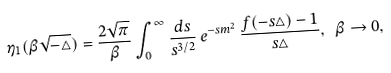<formula> <loc_0><loc_0><loc_500><loc_500>\eta _ { 1 } ( \beta \sqrt { - \triangle } ) = \frac { 2 \sqrt { \pi } } { \beta } \int _ { 0 } ^ { \infty } \frac { { d } s } { s ^ { 3 / 2 } } \, { e } ^ { - s m ^ { 2 } } \, \frac { f ( - s \triangle ) - 1 } { s \triangle } , \ \beta \rightarrow 0 ,</formula> 